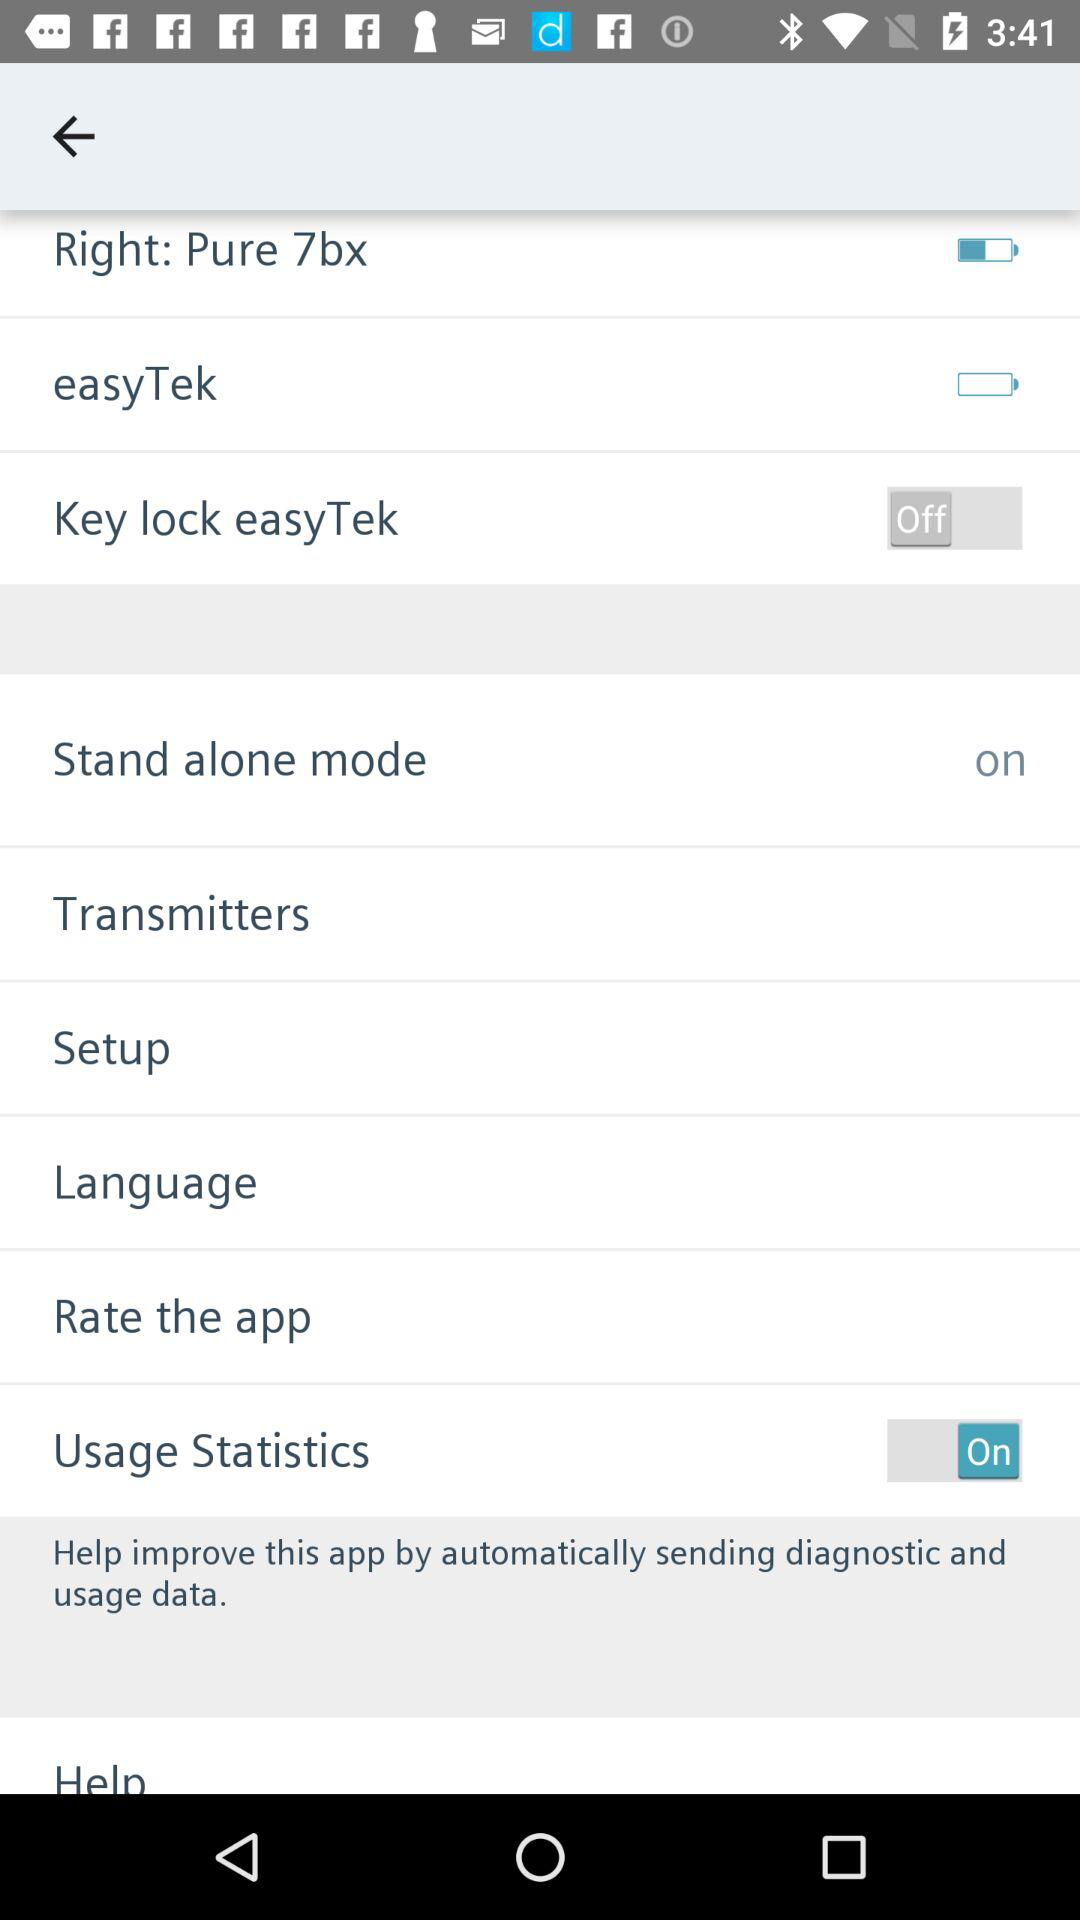What is the status of "Key lock easyTek"? The status of "Key lock easyTek" is "off". 